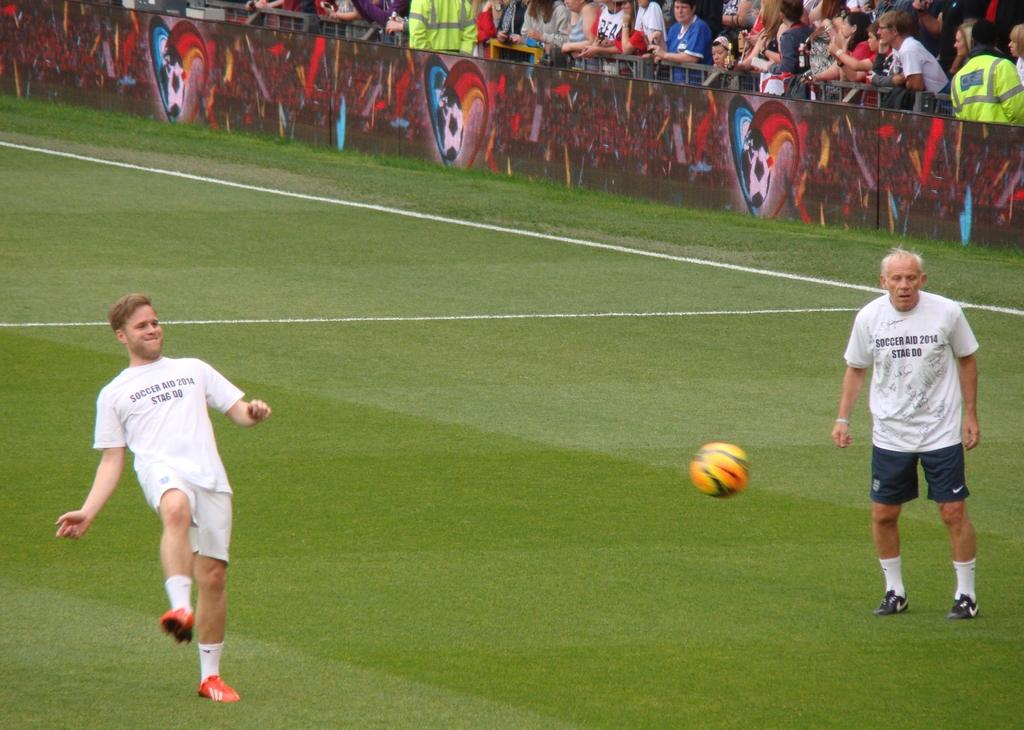<image>
Give a short and clear explanation of the subsequent image. The white shirts says Soccer AID 2014 Stag DO 